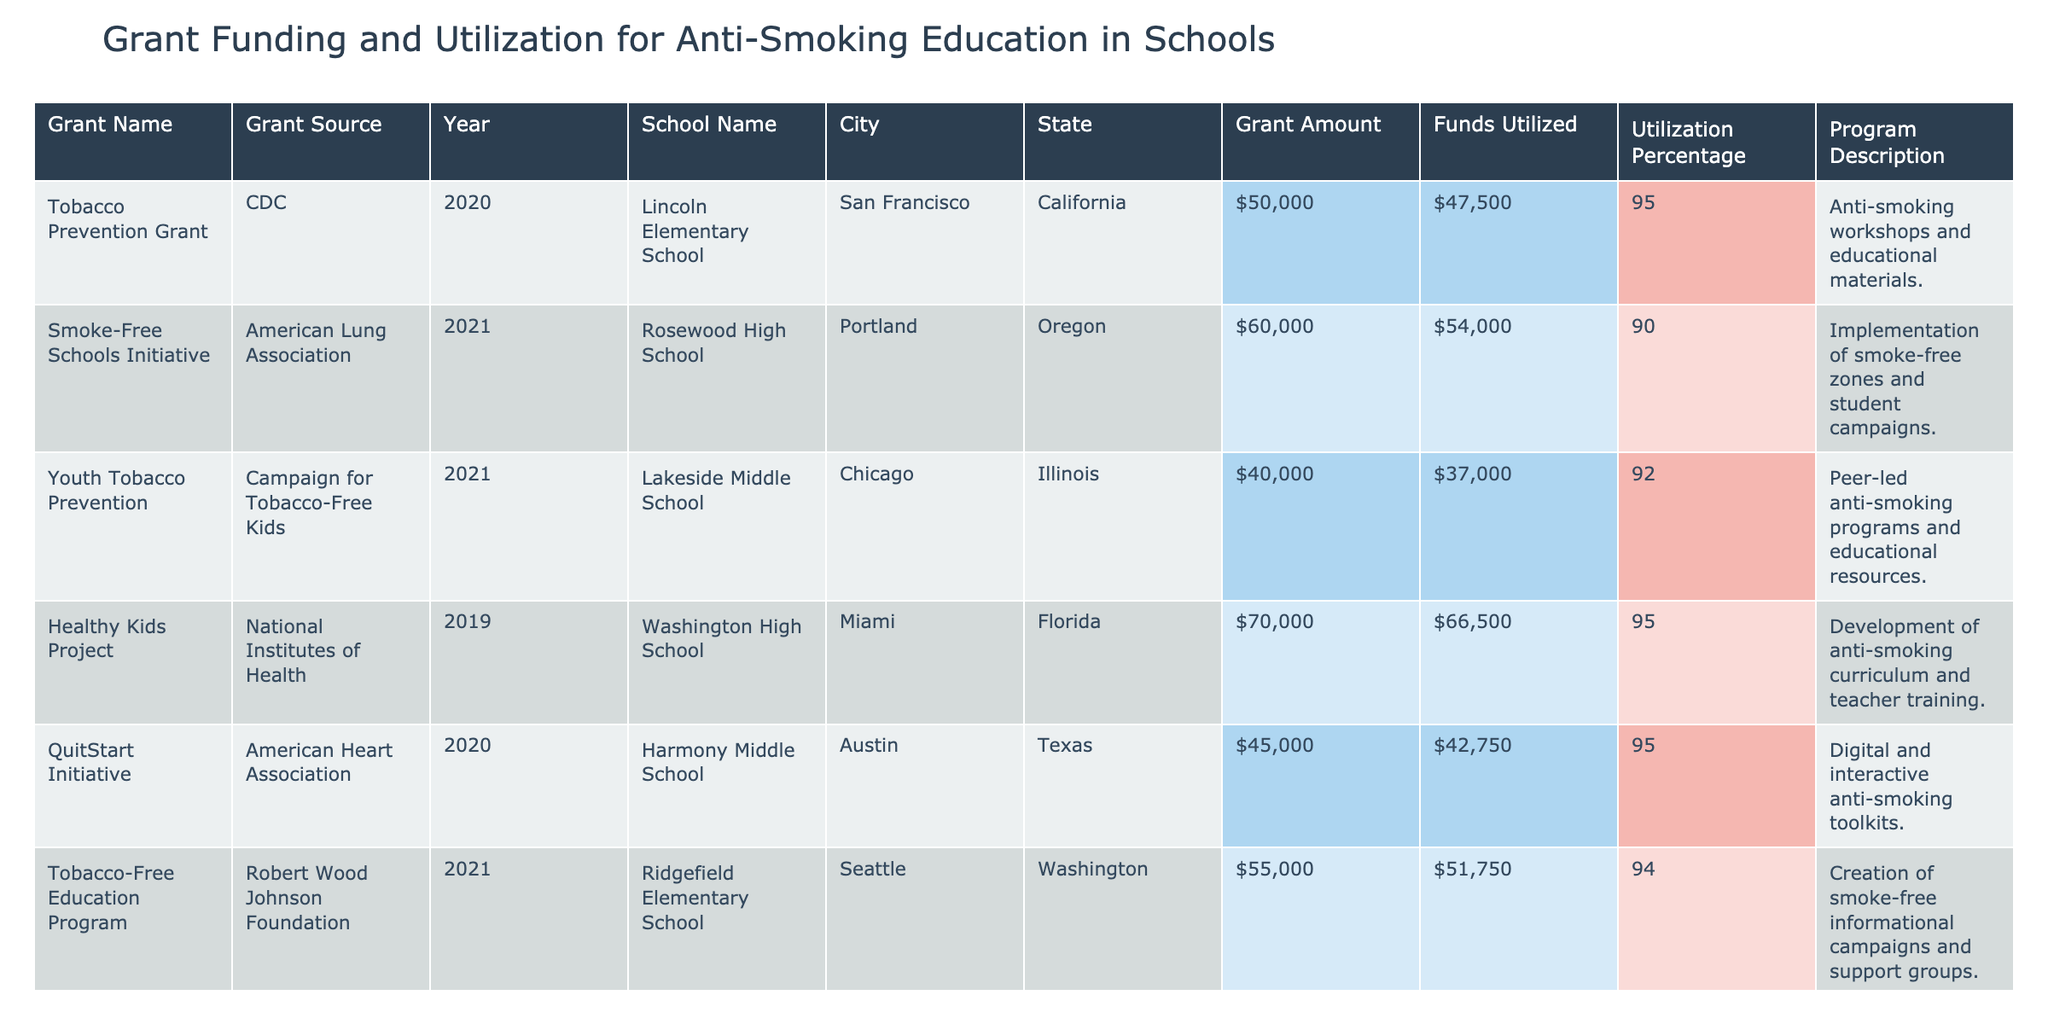What is the total grant amount for the Smoke-Free Schools Initiative? The Smoke-Free Schools Initiative appears in the table, and the "Grant Amount" for that initiative is listed as 60000.
Answer: 60000 Which program has the highest funds utilized? By reviewing the "Funds Utilized" column for all programs, the highest amount is 66500, which corresponds to the Healthy Kids Project.
Answer: 66500 What is the average utilization percentage across all programs listed? To find the average, add all utilization percentages: 95 + 90 + 92 + 95 + 95 + 94 + 95 + 95 + 95 + 95 = 949. Then divide 949 by 10 (the number of programs), which equals 94.9.
Answer: 94.9 Did any school receive a grant amount greater than 60000? Checking the "Grant Amount" column, we see that both the Healthy Kids Project and the Clean Air Initiative received grant amounts greater than 60000 (70000 and 68000, respectively), confirming the answer is yes.
Answer: Yes How much more was utilized in the QuitStart Initiative than in the Youth Tobacco Prevention program? For the QuitStart Initiative, the funds utilized is 42750, and for Youth Tobacco Prevention, it is 37000. The difference is 42750 - 37000 = 5750.
Answer: 5750 Which city had the highest grant amount for anti-smoking education? By reviewing the "City" and "Grant Amount" columns, we find that Los Angeles, with the Clean Air Initiative, received the highest grant amount of 68000 among the listed cities.
Answer: Los Angeles Is there a program that utilized less than 90 percent of its grant amount? By examining the "Utilization Percentage" column for all programs, we see that none of the programs have a utilization percentage below 90, so the answer is no.
Answer: No What is the total amount of funds utilized across all schools? To find the total funds utilized, we sum each program's utilized amount: 47500 + 54000 + 37000 + 66500 + 42750 + 51750 + 58900 + 45600 + 50200 + 64600 =  474100.
Answer: 474100 What proportion of the total grant amount was utilized for the Protect Our Kids program? For the Protect Our Kids program, the grant amount is 53000, and the utilized funds are 50200. The proportion utilized is calculated by dividing 50200 by 53000, which equals approximately 0.947 or 94.7%.
Answer: 94.7% 